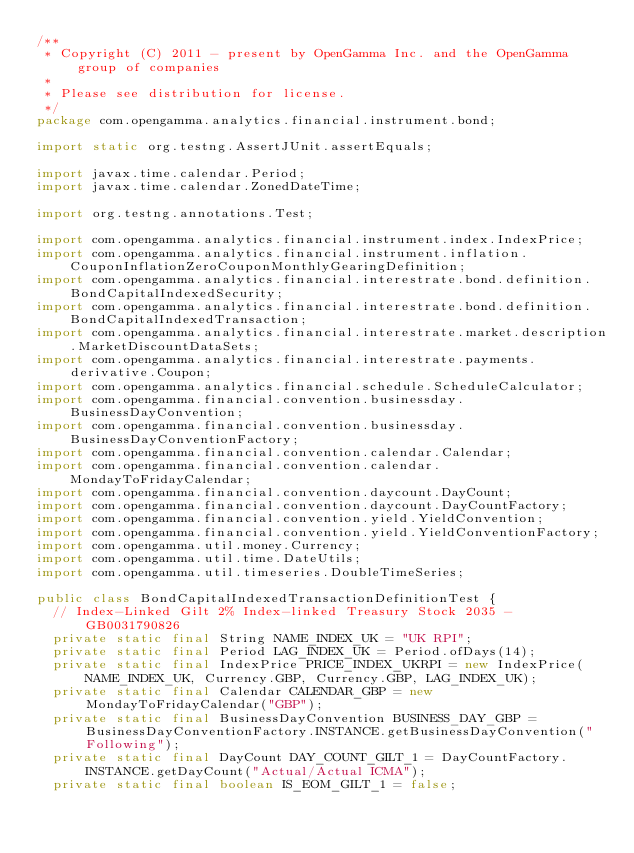<code> <loc_0><loc_0><loc_500><loc_500><_Java_>/**
 * Copyright (C) 2011 - present by OpenGamma Inc. and the OpenGamma group of companies
 * 
 * Please see distribution for license.
 */
package com.opengamma.analytics.financial.instrument.bond;

import static org.testng.AssertJUnit.assertEquals;

import javax.time.calendar.Period;
import javax.time.calendar.ZonedDateTime;

import org.testng.annotations.Test;

import com.opengamma.analytics.financial.instrument.index.IndexPrice;
import com.opengamma.analytics.financial.instrument.inflation.CouponInflationZeroCouponMonthlyGearingDefinition;
import com.opengamma.analytics.financial.interestrate.bond.definition.BondCapitalIndexedSecurity;
import com.opengamma.analytics.financial.interestrate.bond.definition.BondCapitalIndexedTransaction;
import com.opengamma.analytics.financial.interestrate.market.description.MarketDiscountDataSets;
import com.opengamma.analytics.financial.interestrate.payments.derivative.Coupon;
import com.opengamma.analytics.financial.schedule.ScheduleCalculator;
import com.opengamma.financial.convention.businessday.BusinessDayConvention;
import com.opengamma.financial.convention.businessday.BusinessDayConventionFactory;
import com.opengamma.financial.convention.calendar.Calendar;
import com.opengamma.financial.convention.calendar.MondayToFridayCalendar;
import com.opengamma.financial.convention.daycount.DayCount;
import com.opengamma.financial.convention.daycount.DayCountFactory;
import com.opengamma.financial.convention.yield.YieldConvention;
import com.opengamma.financial.convention.yield.YieldConventionFactory;
import com.opengamma.util.money.Currency;
import com.opengamma.util.time.DateUtils;
import com.opengamma.util.timeseries.DoubleTimeSeries;

public class BondCapitalIndexedTransactionDefinitionTest {
  // Index-Linked Gilt 2% Index-linked Treasury Stock 2035 - GB0031790826
  private static final String NAME_INDEX_UK = "UK RPI";
  private static final Period LAG_INDEX_UK = Period.ofDays(14);
  private static final IndexPrice PRICE_INDEX_UKRPI = new IndexPrice(NAME_INDEX_UK, Currency.GBP, Currency.GBP, LAG_INDEX_UK);
  private static final Calendar CALENDAR_GBP = new MondayToFridayCalendar("GBP");
  private static final BusinessDayConvention BUSINESS_DAY_GBP = BusinessDayConventionFactory.INSTANCE.getBusinessDayConvention("Following");
  private static final DayCount DAY_COUNT_GILT_1 = DayCountFactory.INSTANCE.getDayCount("Actual/Actual ICMA");
  private static final boolean IS_EOM_GILT_1 = false;</code> 